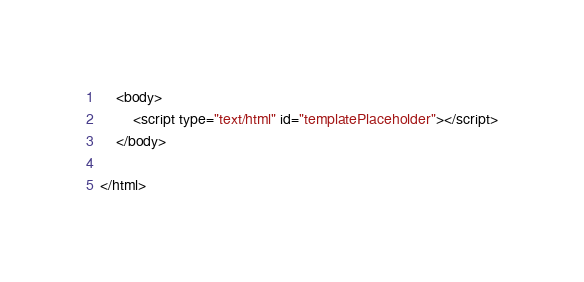<code> <loc_0><loc_0><loc_500><loc_500><_HTML_>	<body>
		<script type="text/html" id="templatePlaceholder"></script>
	</body>

</html></code> 